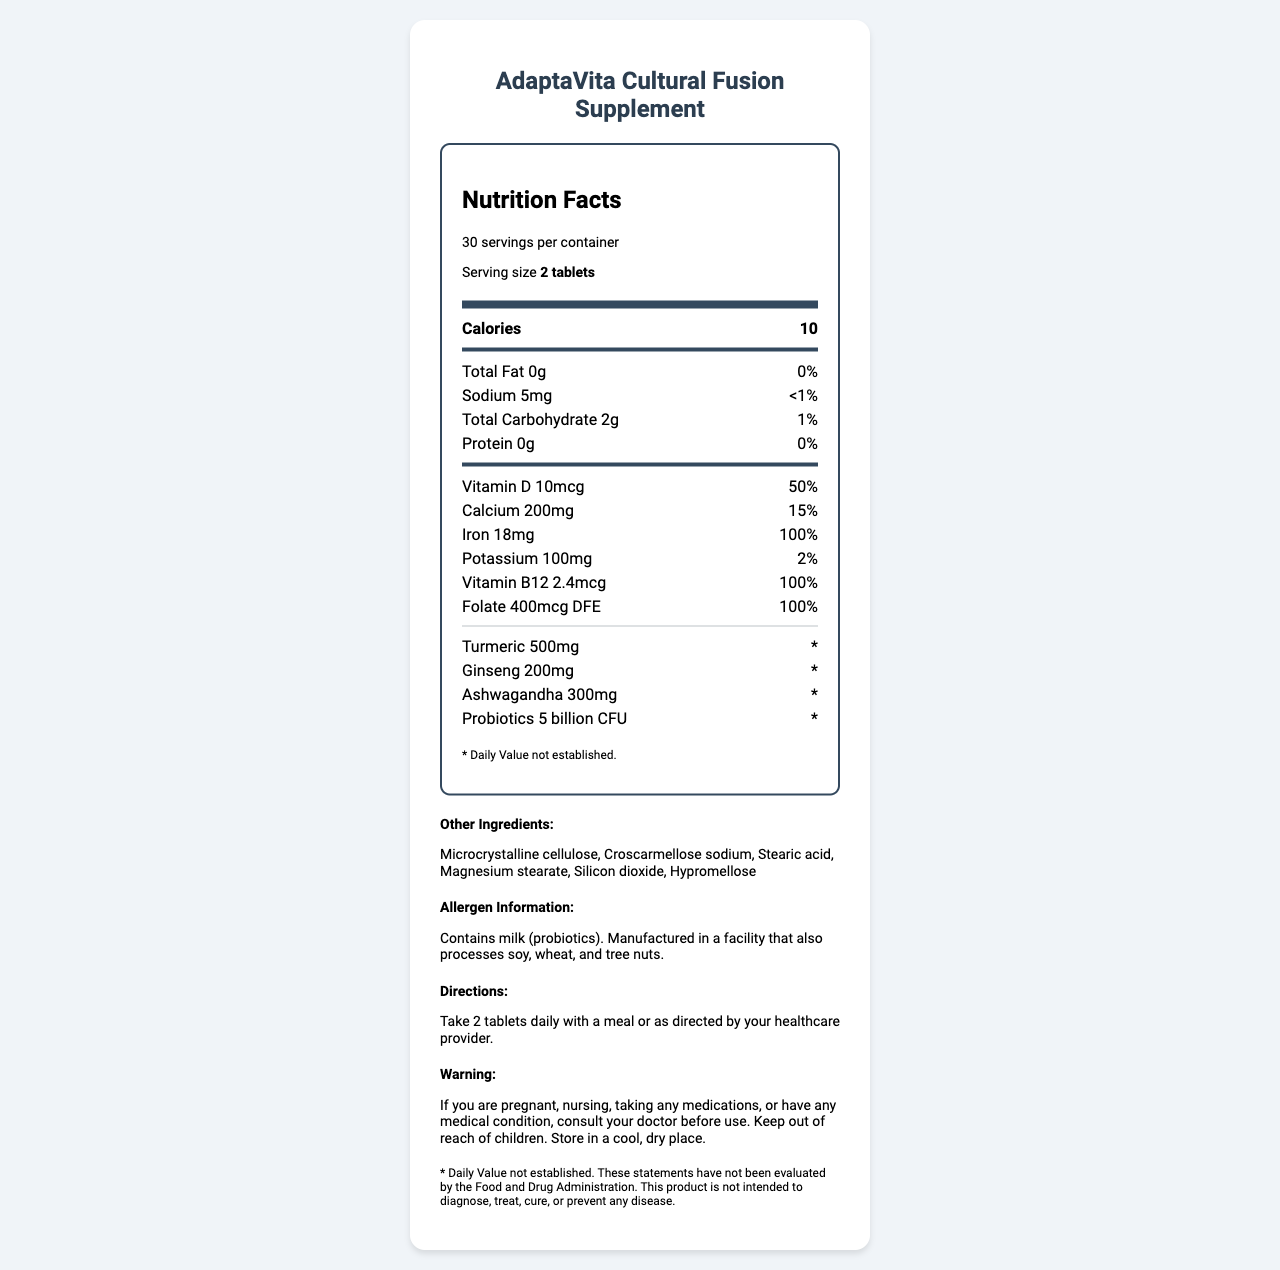what is the serving size? The serving size is listed under the "Nutrition Facts" heading, specifying "Serving size 2 tablets."
Answer: 2 tablets how many servings are in the container? The document states that there are 30 servings per container, found in the "Nutrition Facts" section.
Answer: 30 how many calories are in a serving? The number of calories per serving is listed as 10 under the "Nutrition Facts" heading.
Answer: 10 how much sodium is in a serving? The amount of sodium per serving is specified as 5mg in the nutrition information.
Answer: 5mg what percentage of the daily value for calcium does one serving provide? The daily value percentage for calcium is listed as 15% next to the amount of 200mg in the nutrition information.
Answer: 15% what is the main ingredient that supports digestion in this supplement? A. Turmeric B. Ginseng C. Probiotics The document lists probiotics, which are commonly known for supporting digestion, at 5 billion CFU.
Answer: C which of the following does the supplement contain? I. Iron II. Potassium III. Protein The document's nutrition information lists iron (18mg) and potassium (100mg) but mentions that it has 0g of protein.
Answer: I and II is this supplement suitable for those allergic to milk? The allergen information states that the product contains milk (probiotics).
Answer: No does the supplement provide 100% of the daily value for vitamin B12? The nutrition information indicates that one serving provides 100% of the daily value for vitamin B12 (2.4mcg).
Answer: Yes Summarize the main purpose and key nutritional elements of the AdaptaVita Cultural Fusion Supplement. The document highlights key aspects of the supplement, such as its main purpose to support adaptation through nutrient and culturally significant ingredients. It details the nutrition facts, including high percentages of daily values for iron, vitamin B12, folate, and additional components like turmeric, ginseng, and ashwagandha.
Answer: The AdaptaVita Cultural Fusion Supplement aims to support adaptation to a local diet by offering various vitamins and minerals along with culturally significant ingredients like turmeric, ginseng, and ashwagandha. It provides significant amounts of essential nutrients like iron, vitamin B12, and folate while including digestion-supporting probiotics. how many grams of total fat does the supplement contain per serving? The document lists the total fat as 0g under the nutrition information section.
Answer: 0g what are the instructions for taking this supplement? The directions section clearly states to take 2 tablets daily with a meal or follow the healthcare provider's guidance.
Answer: Take 2 tablets daily with a meal or as directed by your healthcare provider. does this product have an established daily value for turmeric? The document includes a footnote stating "* Daily Value not established." for turmeric.
Answer: No what is the primary purpose of including ashwagandha in the supplement? The document lists ashwagandha and its amount but does not specify its primary purpose.
Answer: Not enough information what action should be taken if a consumer is pregnant or nursing? The warning section advises consulting a doctor if the consumer is pregnant or nursing before using the product.
Answer: Consult your doctor before use. 